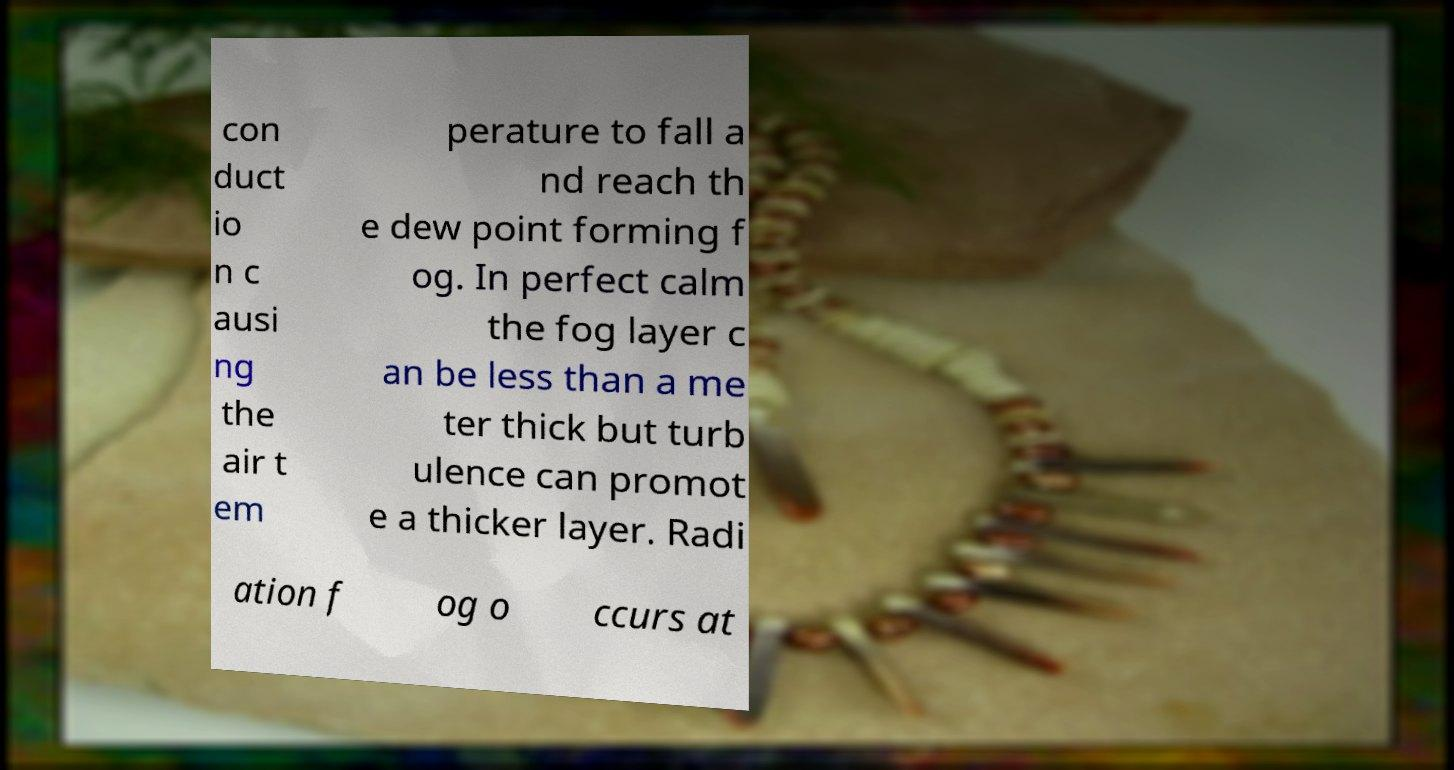Can you read and provide the text displayed in the image?This photo seems to have some interesting text. Can you extract and type it out for me? con duct io n c ausi ng the air t em perature to fall a nd reach th e dew point forming f og. In perfect calm the fog layer c an be less than a me ter thick but turb ulence can promot e a thicker layer. Radi ation f og o ccurs at 